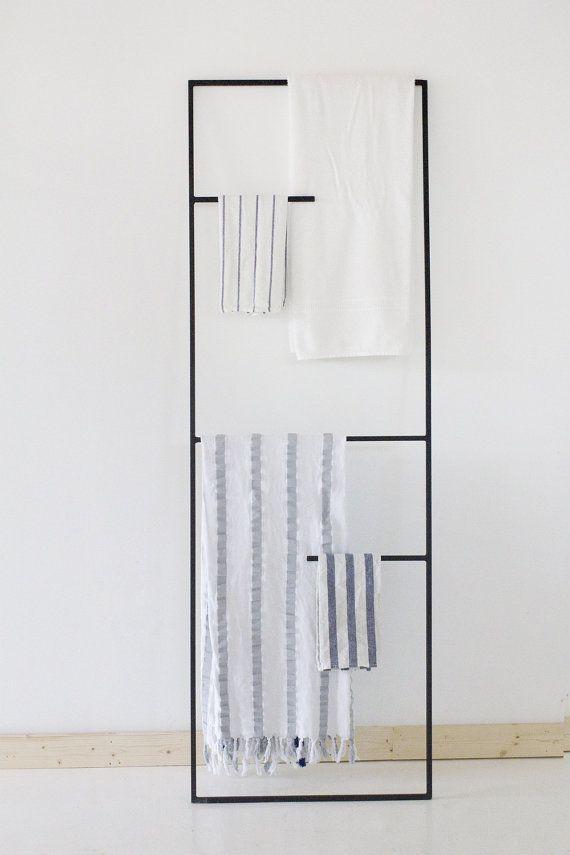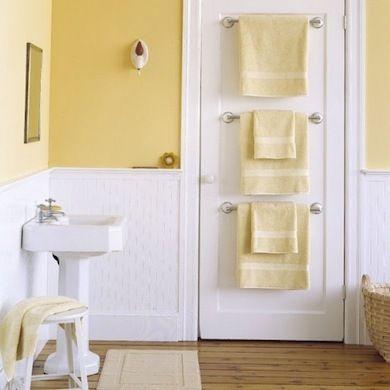The first image is the image on the left, the second image is the image on the right. For the images shown, is this caption "Each image features an over-the-door chrome towel bar with at least 3 bars and at least one hanging towel." true? Answer yes or no. No. 